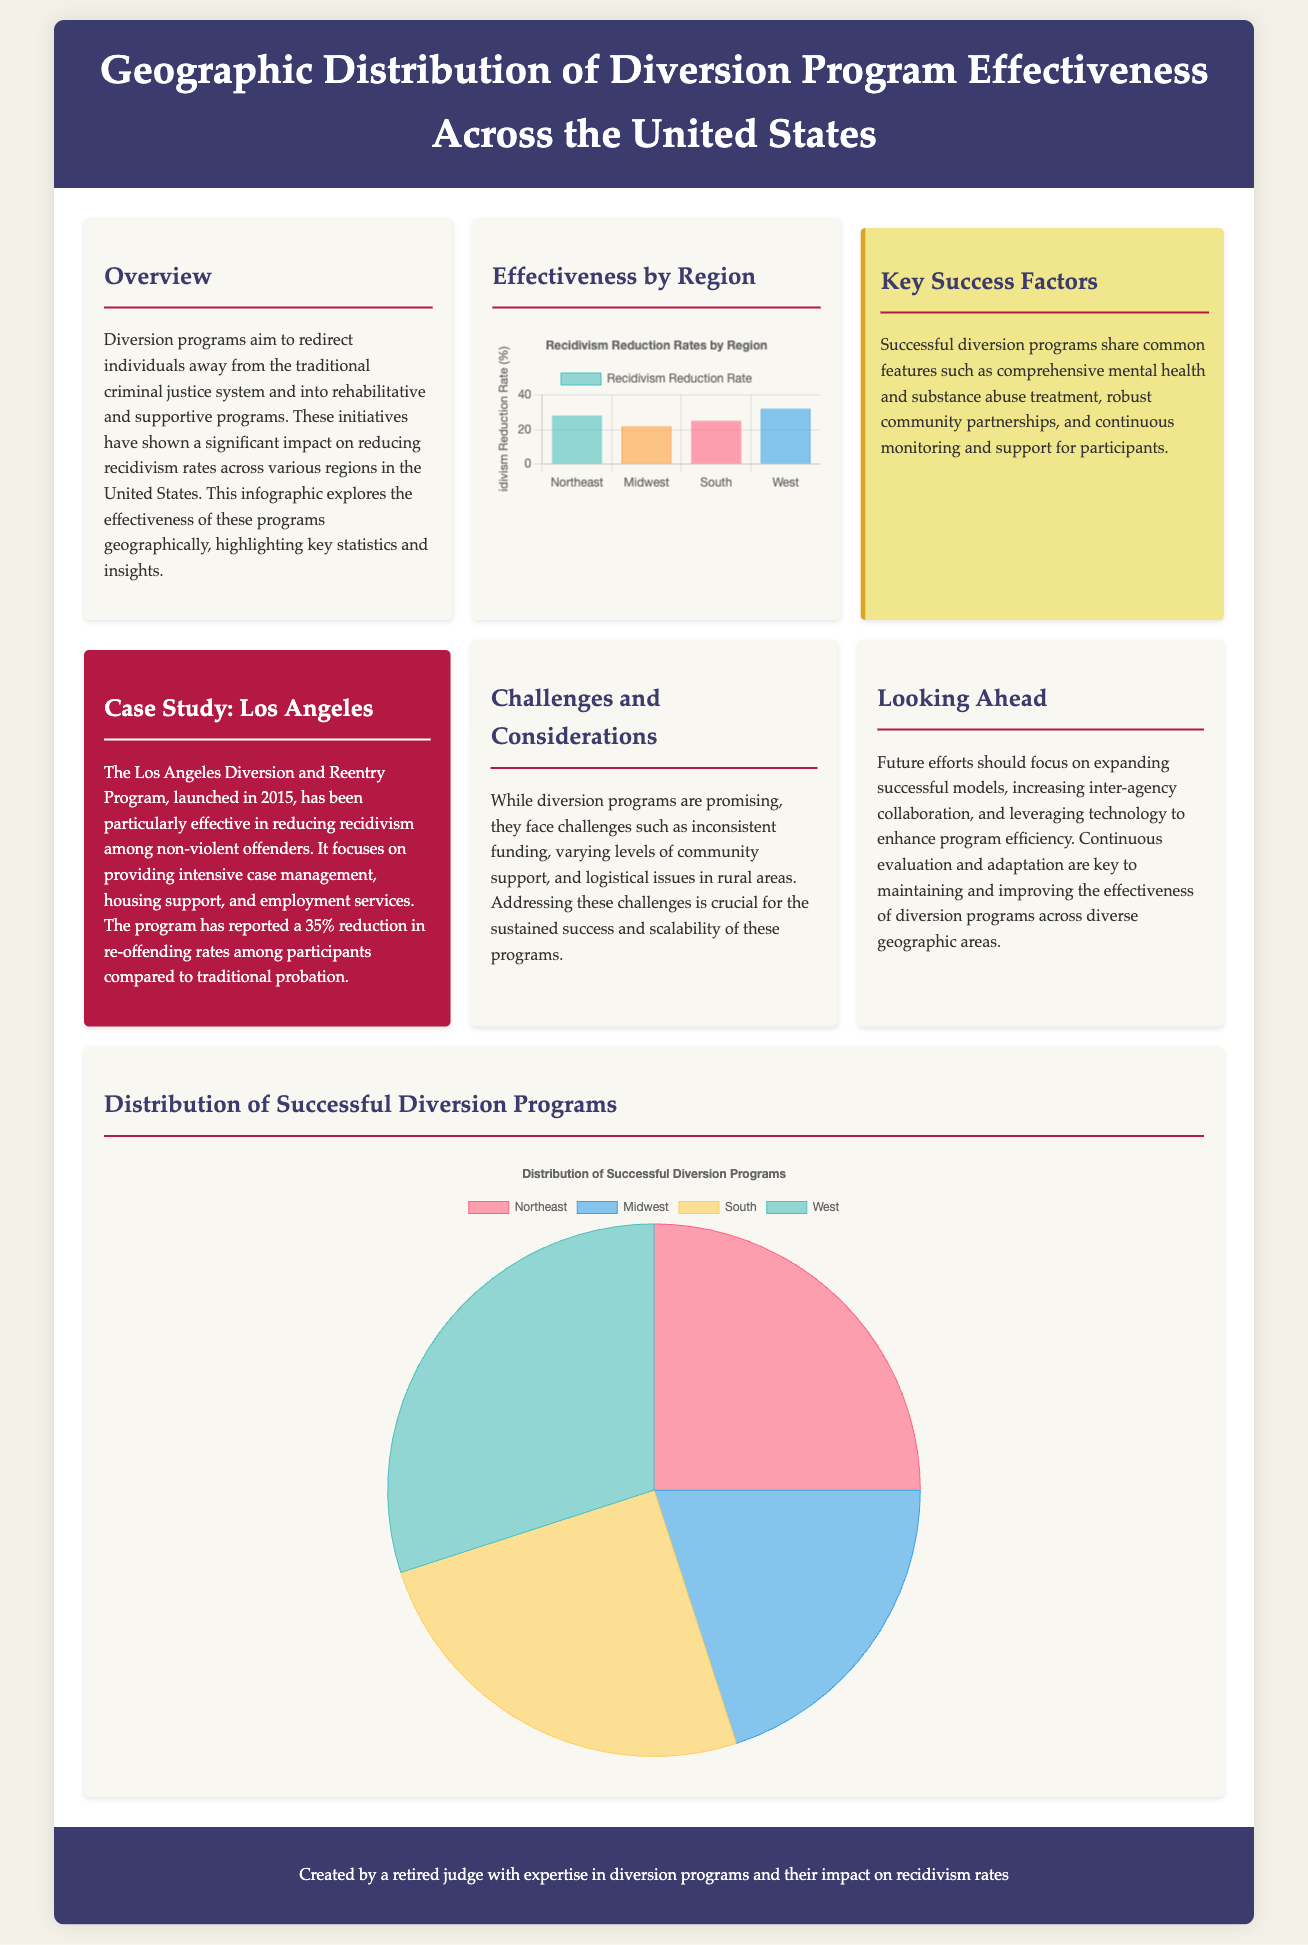what is the title of the infographic? The title of the infographic is presented in the header section at the top of the document.
Answer: Geographic Distribution of Diversion Program Effectiveness Across the United States what is the recidivism reduction rate in the West region? The specific reduction rate for the West region is displayed in the bar chart.
Answer: 32 what percentage of successful diversion programs is located in the Midwest? The distribution chart indicates the percentage of successful programs attributed to the Midwest region.
Answer: 20 what is the primary focus of the Los Angeles Diversion and Reentry Program? The main objectives of the Los Angeles program are outlined in the case study section.
Answer: Intensive case management what are the key success factors for diversion programs? The key success factors are summarized in the specific section of the document detailing program characteristics.
Answer: Comprehensive mental health and substance abuse treatment how much has the Los Angeles program reduced re-offending rates? The reduction in re-offending rates is noted within the case study information of the infographic.
Answer: 35% what type of chart shows the recidivism reduction rates by region? The type of chart used to illustrate the recidivism reduction rates is mentioned in the chart description.
Answer: Bar chart which region has the highest recidivism reduction rate? The region with the highest rate can be determined by comparing the data in the bar chart.
Answer: West what challenges do diversion programs face? A section of the document highlights the various challenges encountered by diversion programs.
Answer: Inconsistent funding 